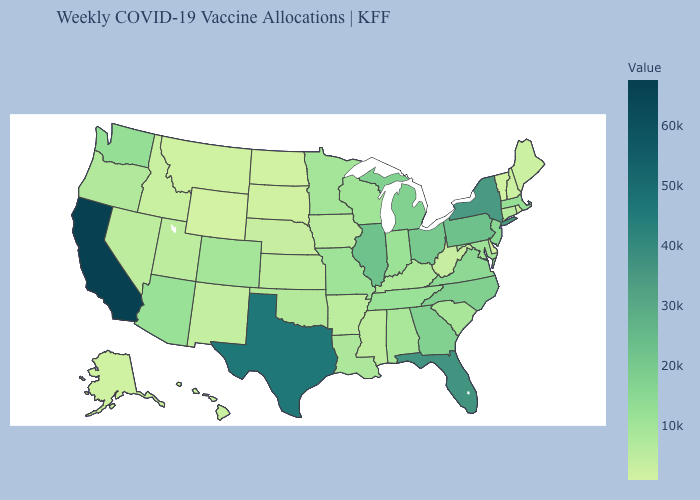Does Tennessee have the highest value in the South?
Short answer required. No. Which states hav the highest value in the Northeast?
Answer briefly. New York. Does Iowa have the highest value in the USA?
Short answer required. No. Among the states that border Massachusetts , does Vermont have the lowest value?
Quick response, please. Yes. 